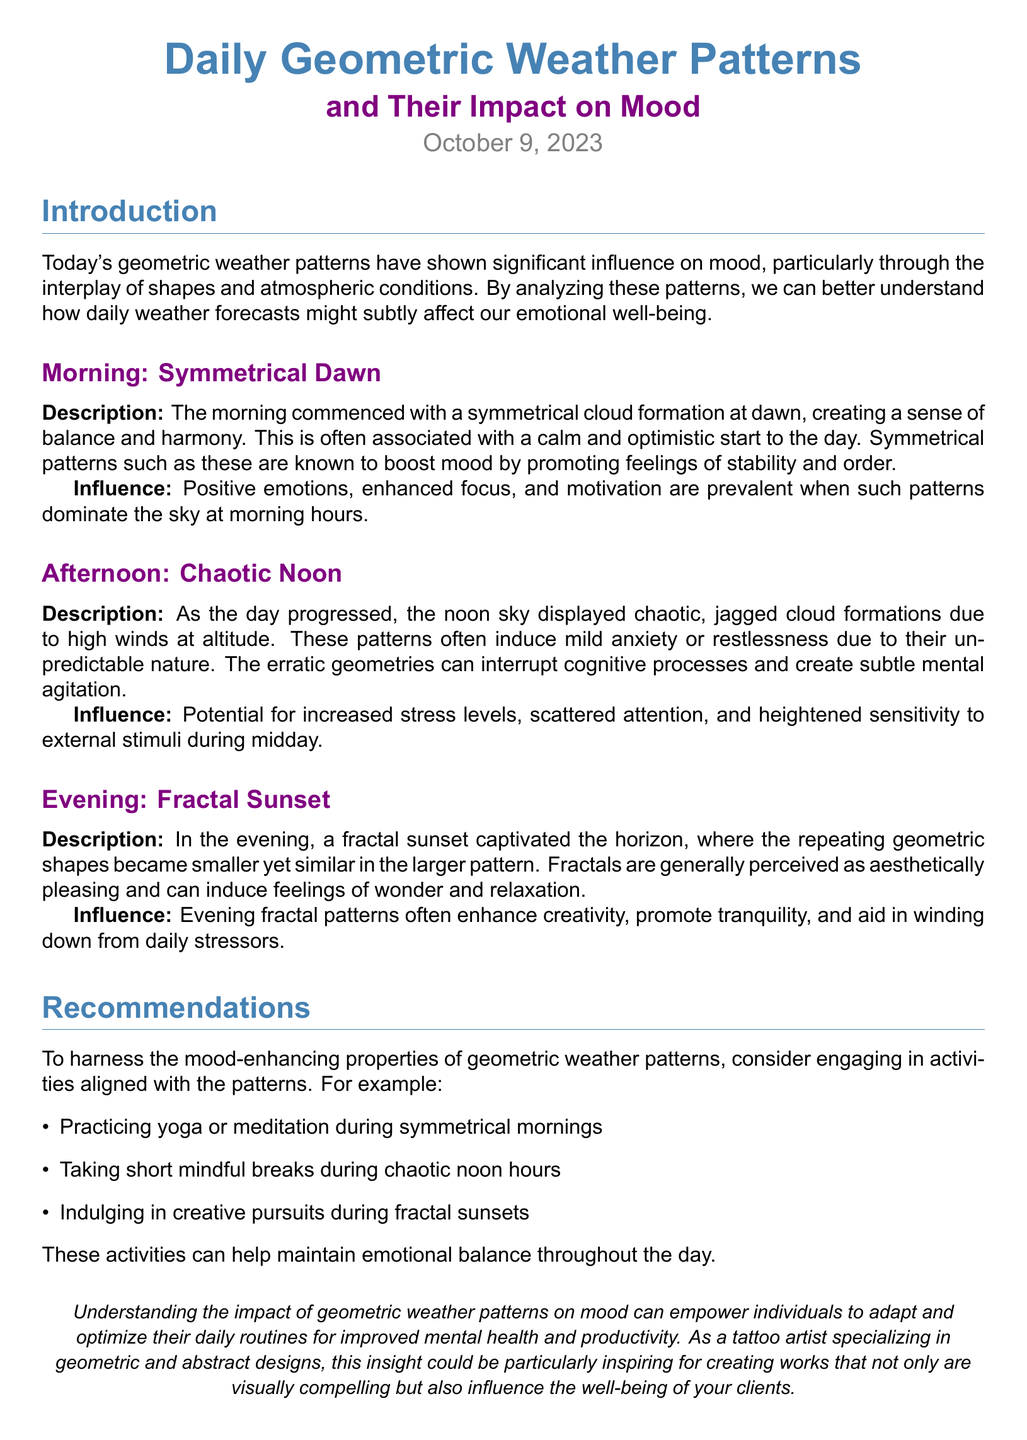What date is the weather report for? The report is dated October 9, 2023, as mentioned at the top of the document.
Answer: October 9, 2023 What cloud formation was observed in the morning? The document describes a "symmetrical cloud formation" at dawn in the morning section.
Answer: symmetrical cloud formation What emotional effects are associated with chaotic noon patterns? The report states that chaotic patterns during noon "induce mild anxiety or restlessness."
Answer: anxiety or restlessness What is recommended during symmetrical mornings? The document suggests "practicing yoga or meditation" as an activity during symmetrical mornings.
Answer: yoga or meditation What pattern captivated the horizon in the evening? The evening section mentions a "fractal sunset" that captivated the horizon.
Answer: fractal sunset What are fractals perceived to induce according to the report? The fractals in the sunset are said to induce "feelings of wonder and relaxation."
Answer: wonder and relaxation Which weather pattern was associated with increased stress levels? The noon article describes chaotic patterns that lead to "increased stress levels."
Answer: chaotic patterns What type of activities should one engage in during fractal sunsets? The report suggests "indulging in creative pursuits" during fractal sunsets.
Answer: creative pursuits What overall impact do geometric weather patterns have on mood? The document concludes that understanding these patterns can help individuals "adapt and optimize their daily routines for improved mental health."
Answer: improved mental health 